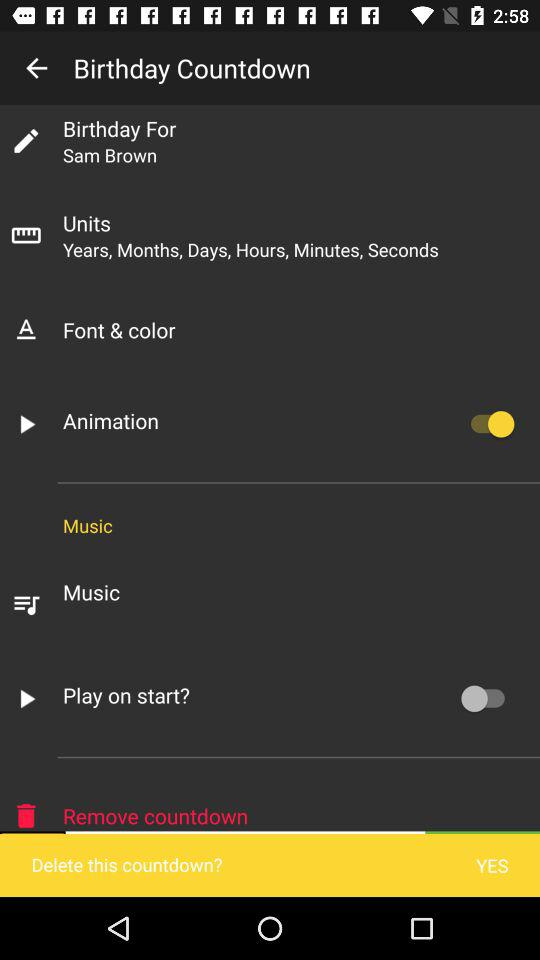Whose birthday is it? It's Sam Brown's birthday. 